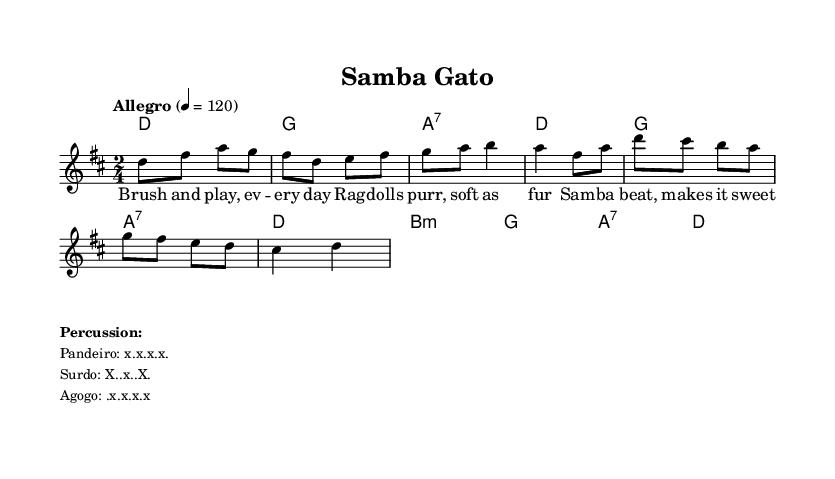What is the key signature of this music? The key signature is D major, which includes two sharps: F# and C#.
Answer: D major What is the time signature of this piece? The time signature is 2/4, indicating there are two beats per measure, and the quarter note gets one beat.
Answer: 2/4 What is the tempo marking given in the score? The tempo marking indicates that the piece should be played at "Allegro," which typically means a fast, lively tempo, specifically set at a quarter note equals 120 beats per minute.
Answer: Allegro How many measures are in the melody section? Counting the measures in the melody line, there are a total of eight measures in the given snippet.
Answer: Eight What instruments are mentioned for percussion? The percussion instruments listed include Pandeiro, Surdo, and Agogo.
Answer: Pandeiro, Surdo, Agogo Which element of music is emphasized by the lyrics? The lyrics emphasize the theme of daily care routines for cats, with the focus on playfulness and affection towards Ragdolls.
Answer: Daily cat care routines What is the last note of the melody? The last note in the melody is a D, which is the fourth note in the melody line representing a resolution.
Answer: D 